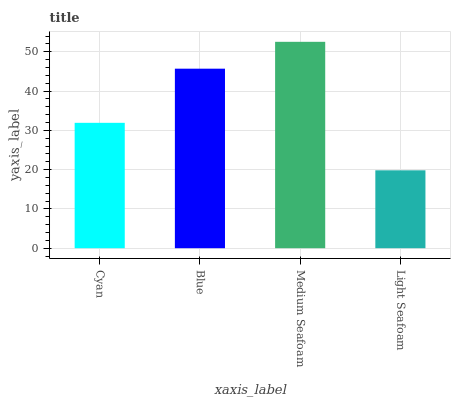Is Blue the minimum?
Answer yes or no. No. Is Blue the maximum?
Answer yes or no. No. Is Blue greater than Cyan?
Answer yes or no. Yes. Is Cyan less than Blue?
Answer yes or no. Yes. Is Cyan greater than Blue?
Answer yes or no. No. Is Blue less than Cyan?
Answer yes or no. No. Is Blue the high median?
Answer yes or no. Yes. Is Cyan the low median?
Answer yes or no. Yes. Is Light Seafoam the high median?
Answer yes or no. No. Is Medium Seafoam the low median?
Answer yes or no. No. 